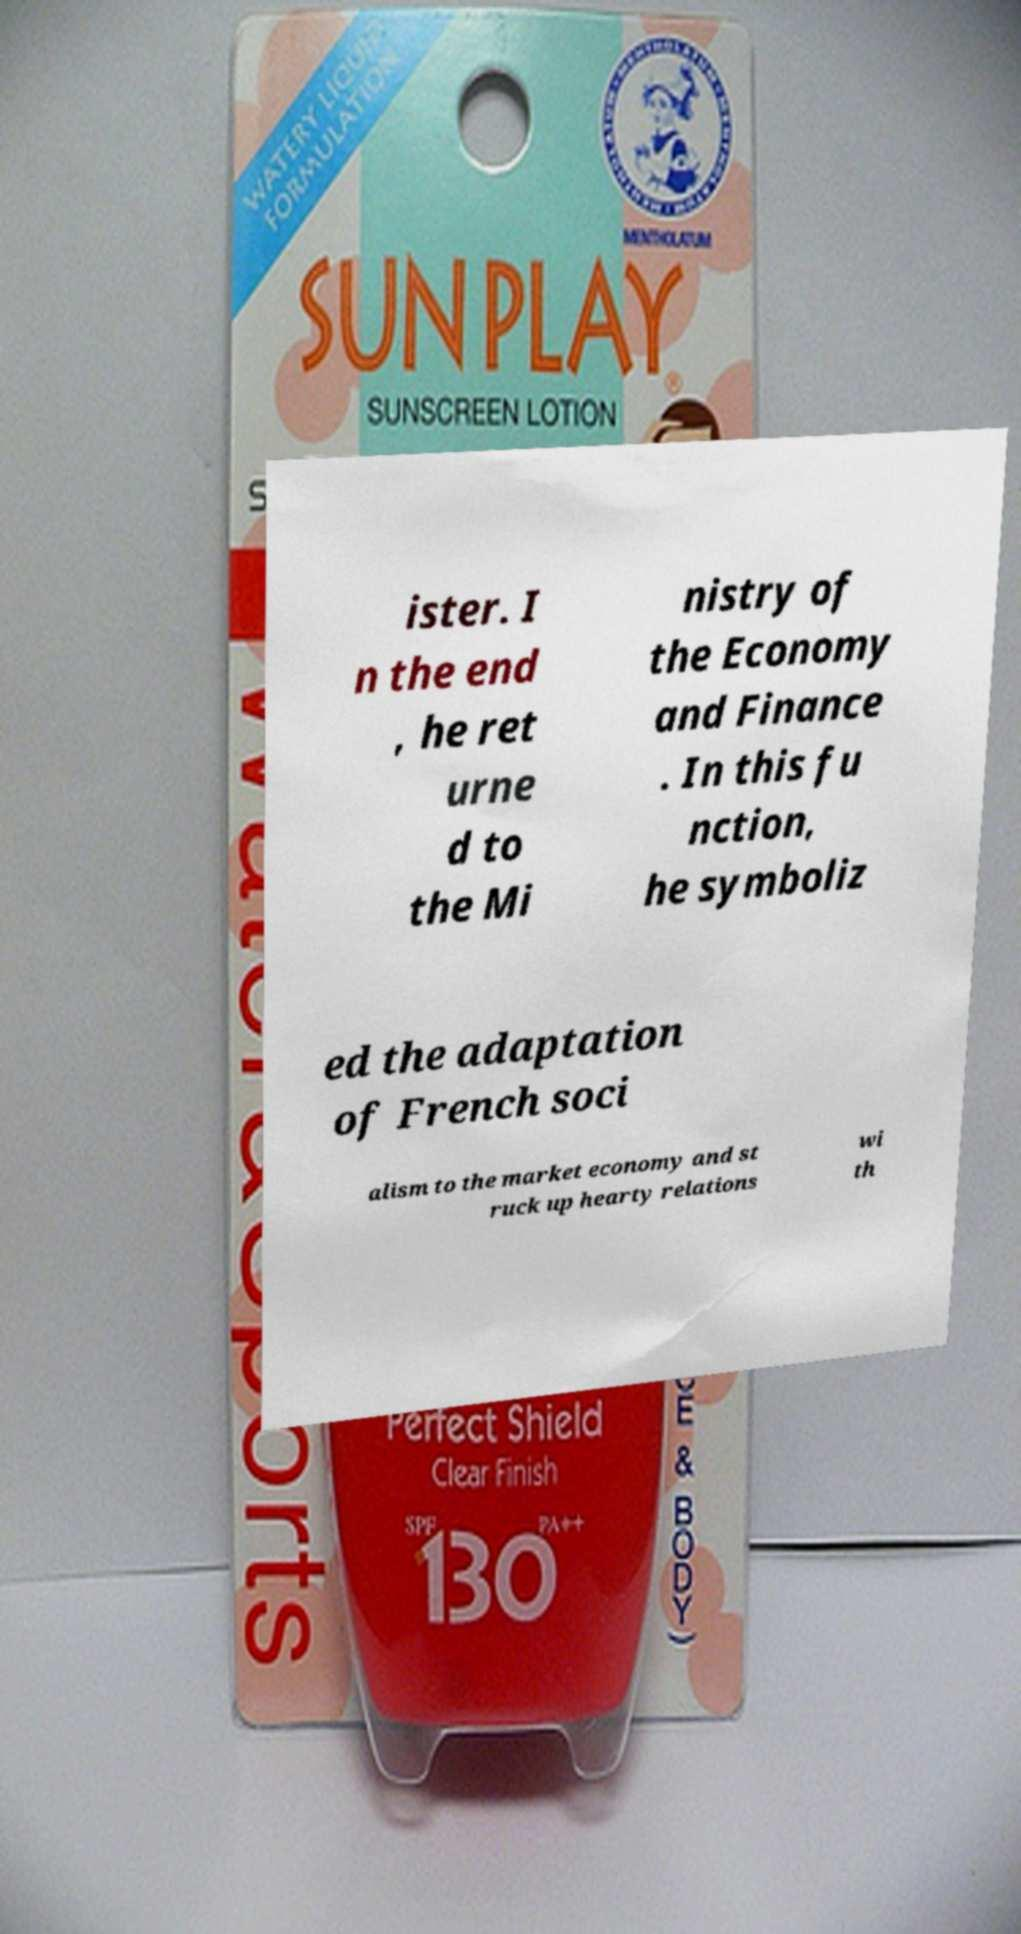Can you read and provide the text displayed in the image?This photo seems to have some interesting text. Can you extract and type it out for me? ister. I n the end , he ret urne d to the Mi nistry of the Economy and Finance . In this fu nction, he symboliz ed the adaptation of French soci alism to the market economy and st ruck up hearty relations wi th 